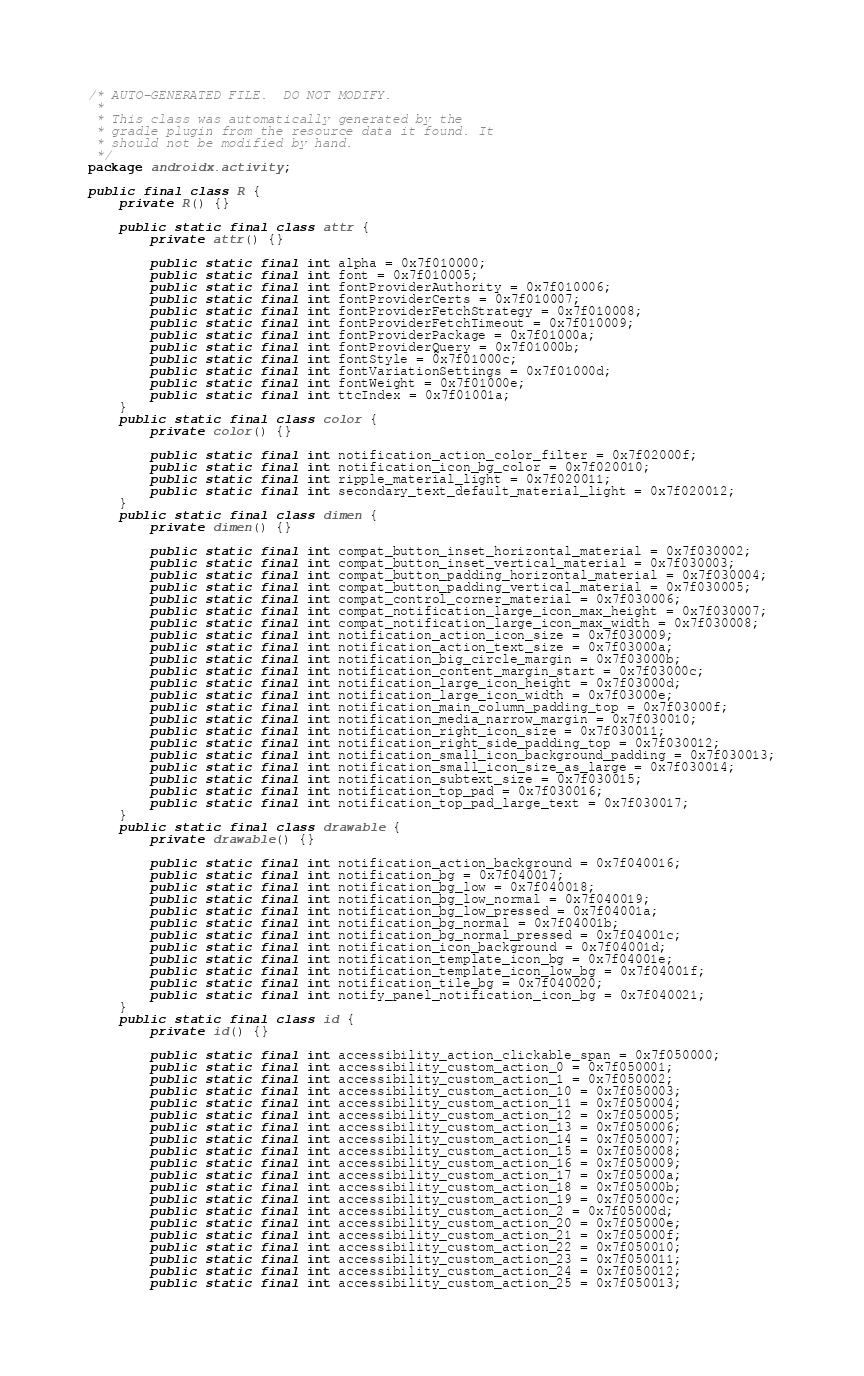Convert code to text. <code><loc_0><loc_0><loc_500><loc_500><_Java_>/* AUTO-GENERATED FILE.  DO NOT MODIFY.
 *
 * This class was automatically generated by the
 * gradle plugin from the resource data it found. It
 * should not be modified by hand.
 */
package androidx.activity;

public final class R {
    private R() {}

    public static final class attr {
        private attr() {}

        public static final int alpha = 0x7f010000;
        public static final int font = 0x7f010005;
        public static final int fontProviderAuthority = 0x7f010006;
        public static final int fontProviderCerts = 0x7f010007;
        public static final int fontProviderFetchStrategy = 0x7f010008;
        public static final int fontProviderFetchTimeout = 0x7f010009;
        public static final int fontProviderPackage = 0x7f01000a;
        public static final int fontProviderQuery = 0x7f01000b;
        public static final int fontStyle = 0x7f01000c;
        public static final int fontVariationSettings = 0x7f01000d;
        public static final int fontWeight = 0x7f01000e;
        public static final int ttcIndex = 0x7f01001a;
    }
    public static final class color {
        private color() {}

        public static final int notification_action_color_filter = 0x7f02000f;
        public static final int notification_icon_bg_color = 0x7f020010;
        public static final int ripple_material_light = 0x7f020011;
        public static final int secondary_text_default_material_light = 0x7f020012;
    }
    public static final class dimen {
        private dimen() {}

        public static final int compat_button_inset_horizontal_material = 0x7f030002;
        public static final int compat_button_inset_vertical_material = 0x7f030003;
        public static final int compat_button_padding_horizontal_material = 0x7f030004;
        public static final int compat_button_padding_vertical_material = 0x7f030005;
        public static final int compat_control_corner_material = 0x7f030006;
        public static final int compat_notification_large_icon_max_height = 0x7f030007;
        public static final int compat_notification_large_icon_max_width = 0x7f030008;
        public static final int notification_action_icon_size = 0x7f030009;
        public static final int notification_action_text_size = 0x7f03000a;
        public static final int notification_big_circle_margin = 0x7f03000b;
        public static final int notification_content_margin_start = 0x7f03000c;
        public static final int notification_large_icon_height = 0x7f03000d;
        public static final int notification_large_icon_width = 0x7f03000e;
        public static final int notification_main_column_padding_top = 0x7f03000f;
        public static final int notification_media_narrow_margin = 0x7f030010;
        public static final int notification_right_icon_size = 0x7f030011;
        public static final int notification_right_side_padding_top = 0x7f030012;
        public static final int notification_small_icon_background_padding = 0x7f030013;
        public static final int notification_small_icon_size_as_large = 0x7f030014;
        public static final int notification_subtext_size = 0x7f030015;
        public static final int notification_top_pad = 0x7f030016;
        public static final int notification_top_pad_large_text = 0x7f030017;
    }
    public static final class drawable {
        private drawable() {}

        public static final int notification_action_background = 0x7f040016;
        public static final int notification_bg = 0x7f040017;
        public static final int notification_bg_low = 0x7f040018;
        public static final int notification_bg_low_normal = 0x7f040019;
        public static final int notification_bg_low_pressed = 0x7f04001a;
        public static final int notification_bg_normal = 0x7f04001b;
        public static final int notification_bg_normal_pressed = 0x7f04001c;
        public static final int notification_icon_background = 0x7f04001d;
        public static final int notification_template_icon_bg = 0x7f04001e;
        public static final int notification_template_icon_low_bg = 0x7f04001f;
        public static final int notification_tile_bg = 0x7f040020;
        public static final int notify_panel_notification_icon_bg = 0x7f040021;
    }
    public static final class id {
        private id() {}

        public static final int accessibility_action_clickable_span = 0x7f050000;
        public static final int accessibility_custom_action_0 = 0x7f050001;
        public static final int accessibility_custom_action_1 = 0x7f050002;
        public static final int accessibility_custom_action_10 = 0x7f050003;
        public static final int accessibility_custom_action_11 = 0x7f050004;
        public static final int accessibility_custom_action_12 = 0x7f050005;
        public static final int accessibility_custom_action_13 = 0x7f050006;
        public static final int accessibility_custom_action_14 = 0x7f050007;
        public static final int accessibility_custom_action_15 = 0x7f050008;
        public static final int accessibility_custom_action_16 = 0x7f050009;
        public static final int accessibility_custom_action_17 = 0x7f05000a;
        public static final int accessibility_custom_action_18 = 0x7f05000b;
        public static final int accessibility_custom_action_19 = 0x7f05000c;
        public static final int accessibility_custom_action_2 = 0x7f05000d;
        public static final int accessibility_custom_action_20 = 0x7f05000e;
        public static final int accessibility_custom_action_21 = 0x7f05000f;
        public static final int accessibility_custom_action_22 = 0x7f050010;
        public static final int accessibility_custom_action_23 = 0x7f050011;
        public static final int accessibility_custom_action_24 = 0x7f050012;
        public static final int accessibility_custom_action_25 = 0x7f050013;</code> 